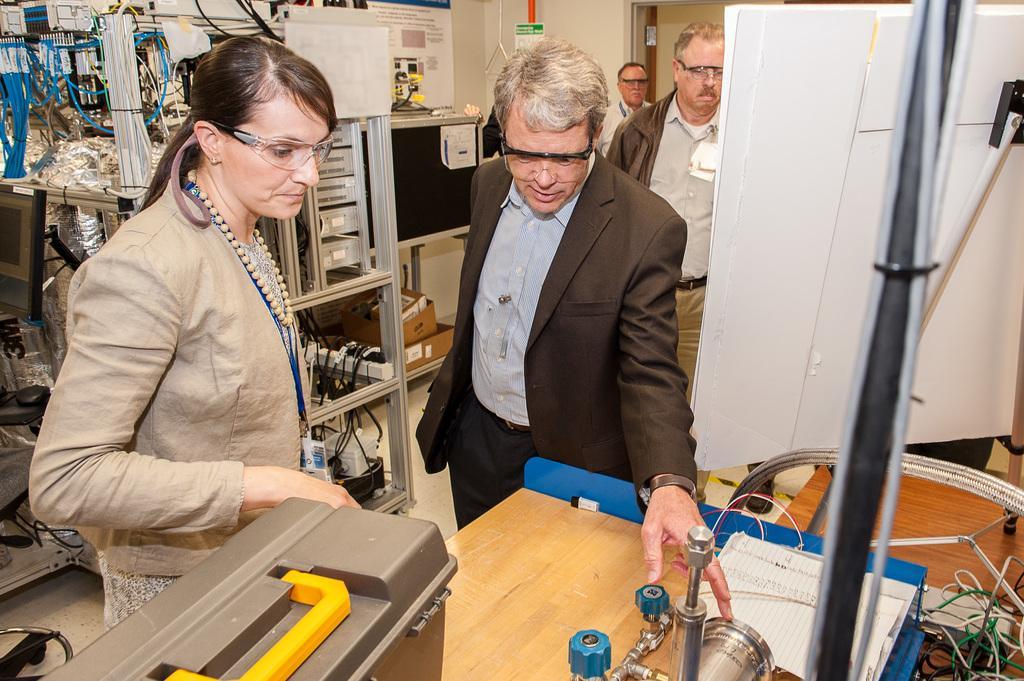Can you describe this image briefly? In the center of the image we can see two persons are standing. In front of them, we can see one table. On the table, we can see one box, machine, book and a few other objects. In the background there is a wall, tables, one monitor, chair, board, wires, machines, banners, two persons are standing and a few other objects. 